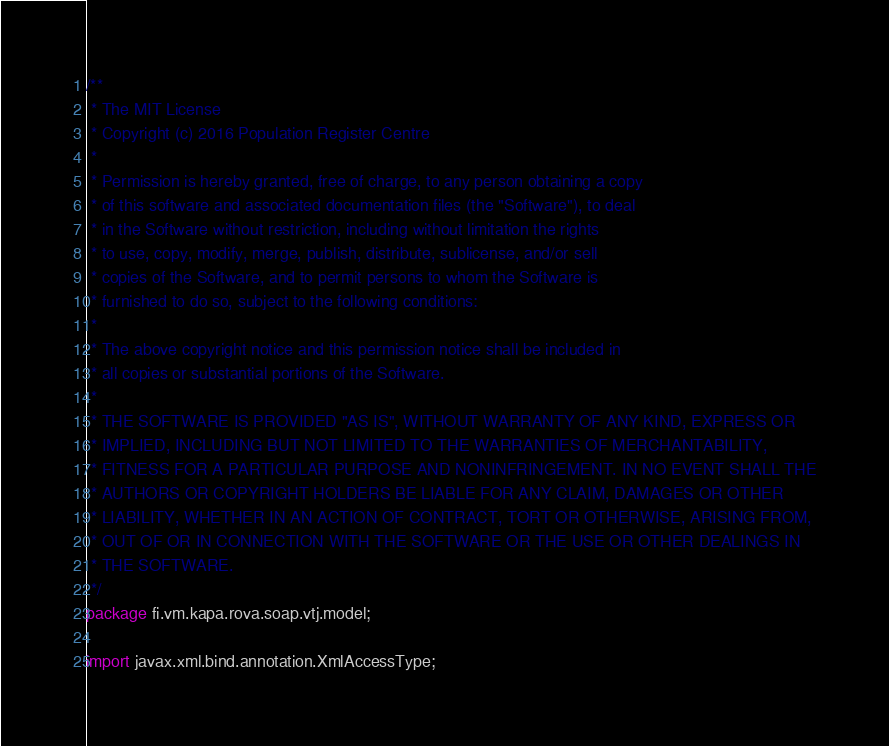<code> <loc_0><loc_0><loc_500><loc_500><_Java_>/**
 * The MIT License
 * Copyright (c) 2016 Population Register Centre
 *
 * Permission is hereby granted, free of charge, to any person obtaining a copy
 * of this software and associated documentation files (the "Software"), to deal
 * in the Software without restriction, including without limitation the rights
 * to use, copy, modify, merge, publish, distribute, sublicense, and/or sell
 * copies of the Software, and to permit persons to whom the Software is
 * furnished to do so, subject to the following conditions:
 *
 * The above copyright notice and this permission notice shall be included in
 * all copies or substantial portions of the Software.
 *
 * THE SOFTWARE IS PROVIDED "AS IS", WITHOUT WARRANTY OF ANY KIND, EXPRESS OR
 * IMPLIED, INCLUDING BUT NOT LIMITED TO THE WARRANTIES OF MERCHANTABILITY,
 * FITNESS FOR A PARTICULAR PURPOSE AND NONINFRINGEMENT. IN NO EVENT SHALL THE
 * AUTHORS OR COPYRIGHT HOLDERS BE LIABLE FOR ANY CLAIM, DAMAGES OR OTHER
 * LIABILITY, WHETHER IN AN ACTION OF CONTRACT, TORT OR OTHERWISE, ARISING FROM,
 * OUT OF OR IN CONNECTION WITH THE SOFTWARE OR THE USE OR OTHER DEALINGS IN
 * THE SOFTWARE.
 */
package fi.vm.kapa.rova.soap.vtj.model;

import javax.xml.bind.annotation.XmlAccessType;</code> 